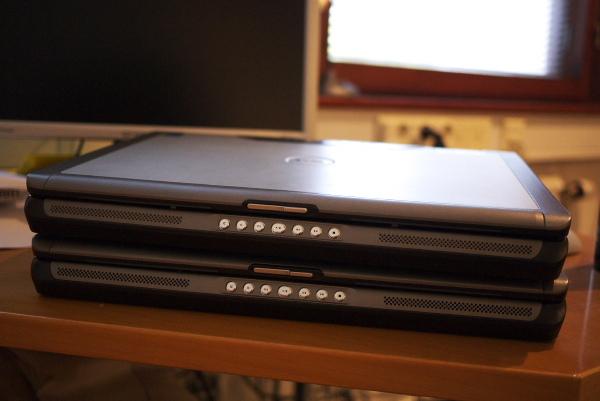How many laptops?
Concise answer only. 2. What is on the table?
Concise answer only. Laptops. Are the items on the floor?
Short answer required. No. What is stacked up?
Keep it brief. Laptops. Is this the front or back of the laptops?
Write a very short answer. Front. 